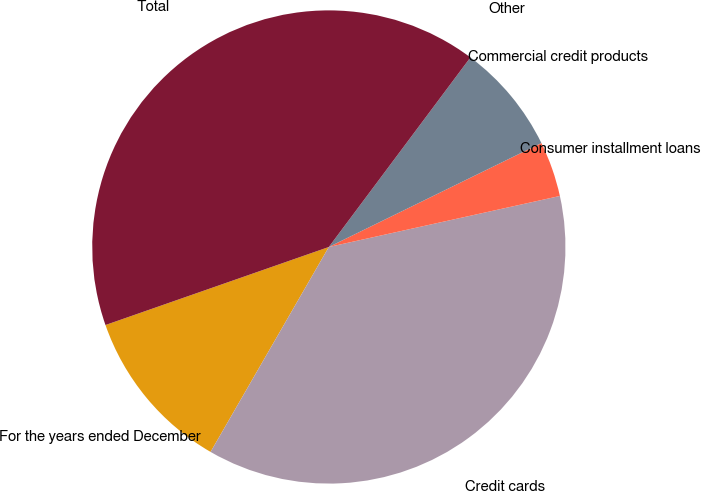Convert chart. <chart><loc_0><loc_0><loc_500><loc_500><pie_chart><fcel>For the years ended December<fcel>Credit cards<fcel>Consumer installment loans<fcel>Commercial credit products<fcel>Other<fcel>Total<nl><fcel>11.32%<fcel>36.79%<fcel>3.78%<fcel>7.55%<fcel>0.0%<fcel>40.56%<nl></chart> 